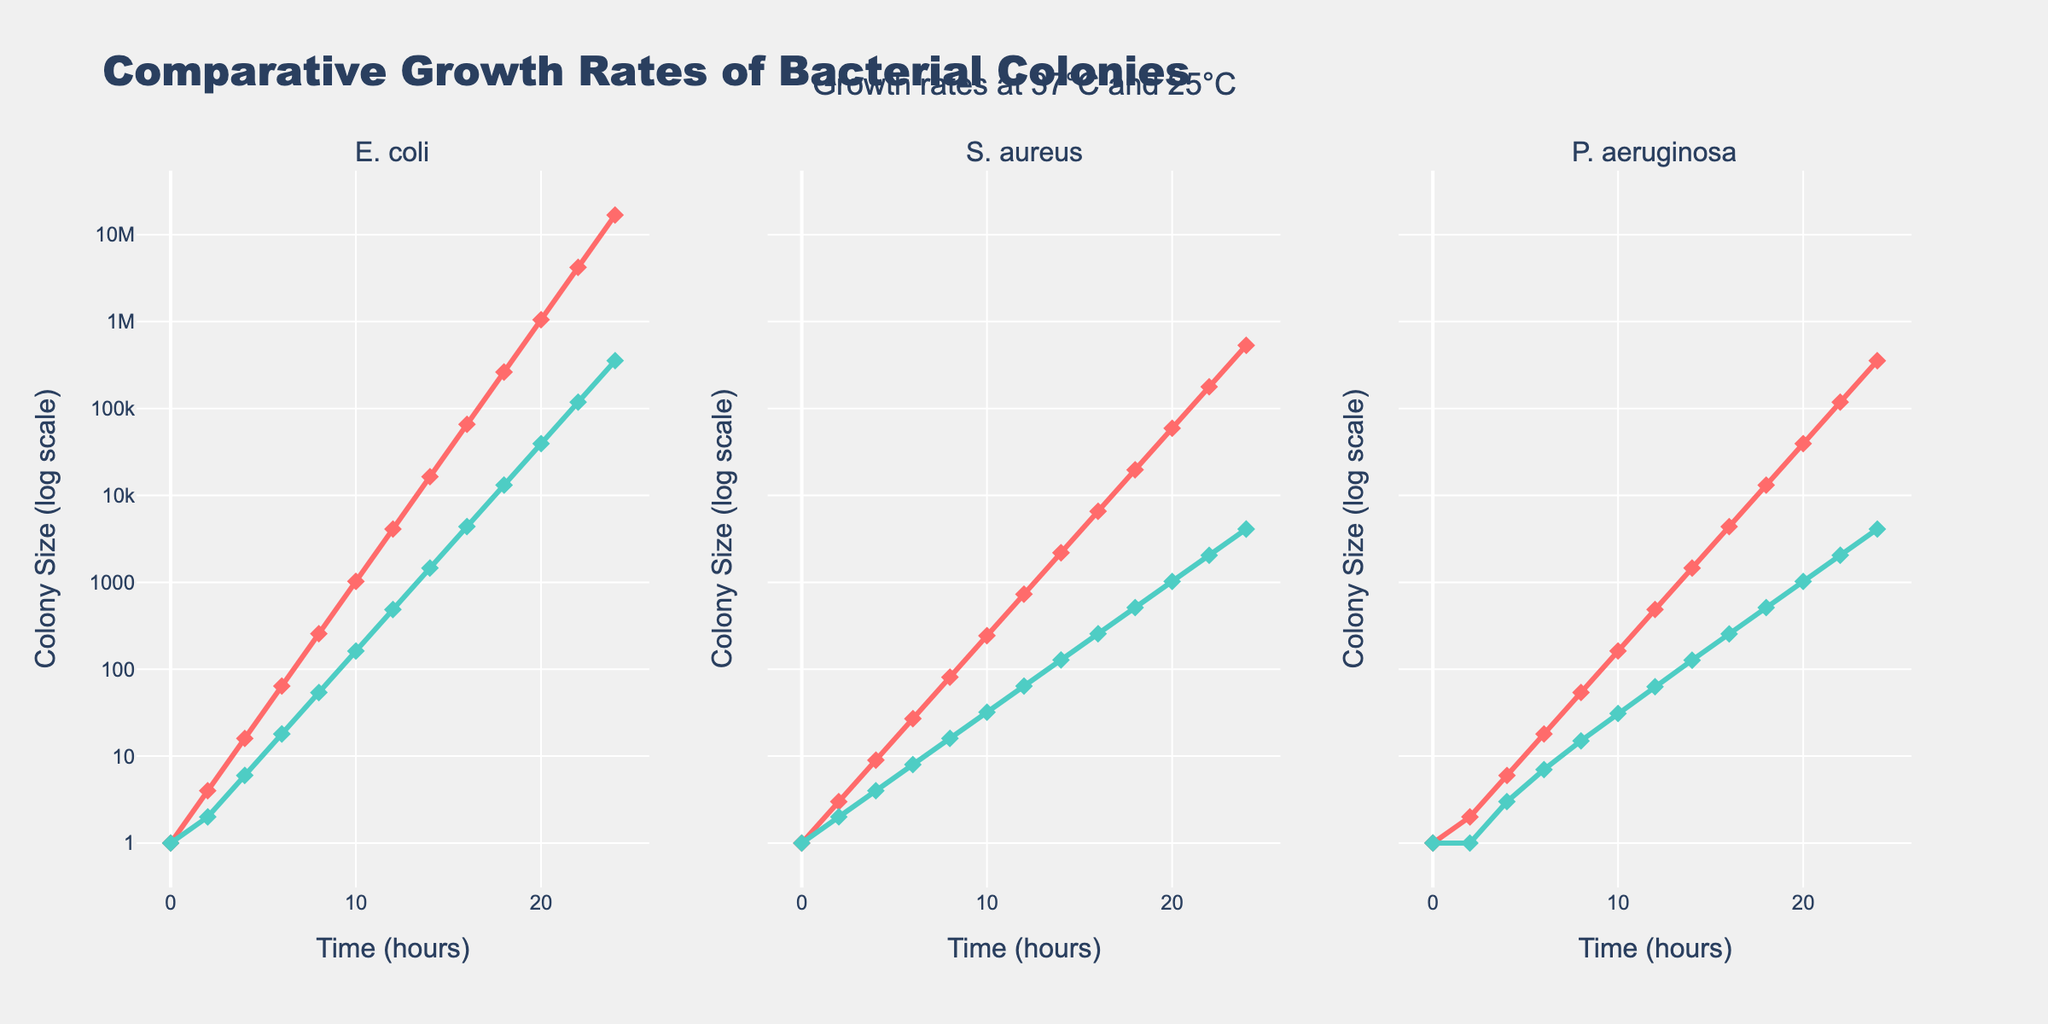What is the trend in the growth of E. coli at 37°C compared to E. coli at 25°C? Compare the lines representing E. coli at 37°C and 25°C. E. coli at 37°C shows an exponential increase in colony size, while the growth at 25°C is slower and less steep. This indicates faster and more robust growth at 37°C.
Answer: E. coli grows faster at 37°C At the 10-hour mark, which bacterial strain has the highest colony size at 25°C? Check the y-values at the 10-hour mark for each strain at 25°C. S. aureus, E. coli, and P. aeruginosa have colony sizes of 31, 162, and 31 respectively. E. coli has the highest colony size.
Answer: E. coli How does the colony size of S. aureus at 37°C at 16 hours compare to its size at 25°C at the same time point? At 16 hours, S. aureus at 37°C has a colony size of 6561, while at 25°C, it has 256. Comparing these two values shows significantly greater growth at 37°C.
Answer: 6561 vs 256 Which bacterial strain exhibited the most significant growth change from 0 to 24 hours at 37°C? Review the growth data for each strain at 37°C from 0 to 24 hours. E. coli grows from 1 to 16777216, S. aureus from 1 to 531441, and P. aeruginosa from 1 to 354294. E. coli shows the largest change.
Answer: E. coli Comparing the growth rates of P. aeruginosa at both temperatures, which condition shows a more substantial increase in colony size over the 24-hour period? Examine the growth rate of P. aeruginosa at 37°C and 25°C. At 37°C, the growth is exponential, reaching a higher colony size compared to the more modest increase at 25°C.
Answer: 37°C If the colony size of S. aureus at 25°C doubles every 2 hours, what will its size be at 18 hours assuming it starts doubling from its 16-hour size? At 16 hours, S. aureus at 25°C has a size of 256. If this doubles every 2 hours: 256 × 2 = 512 at 18 hours.
Answer: 512 By how much does the colony size of E. coli at 37°C surpass that of E. coli at 25°C by the 12-hour mark? At 12 hours, E. coli at 37°C is 4096, while at 25°C it's 486. The difference is 4096 - 486.
Answer: 3610 Between 6 to 12 hours, by how many times did the colony size of P. aeruginosa at 37°C increase? At 6 hours, P. aeruginosa at 37°C is 18, and at 12 hours, it is 486. The fold increase is 486 / 18.
Answer: 27 times Visually, which bacterial strain at 37°C appears to have the steepest growth curve? Look at the slope of the lines plotted for each strain at 37°C. E. coli has the steepest and sharpest increase, indicating the steepest growth curve.
Answer: E. coli Throughout the entire 24-hour period, which condition shows the most consistent (least variable) growth rate visually? Examine the smoothness and consistency of the growth lines. E. coli at 25°C shows a relatively consistent and smoother growth rate compared to others.
Answer: E. coli at 25°C 